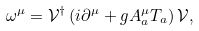Convert formula to latex. <formula><loc_0><loc_0><loc_500><loc_500>\omega ^ { \mu } = { \mathcal { V } } ^ { \dag } \left ( i \partial ^ { \mu } + g A _ { a } ^ { \mu } T _ { a } \right ) { \mathcal { V } } ,</formula> 